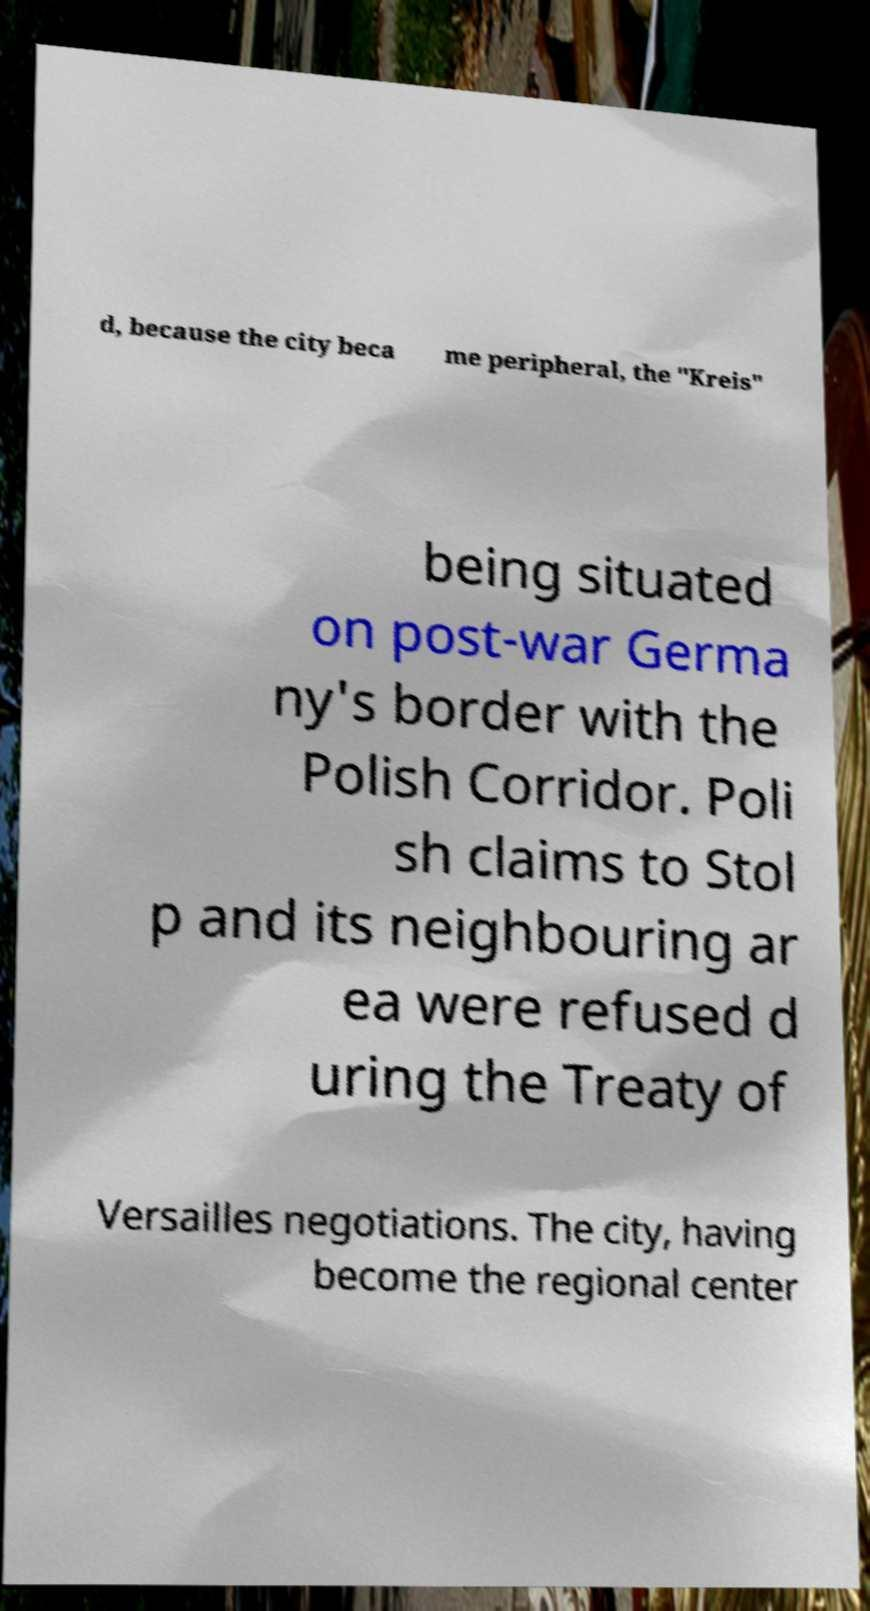There's text embedded in this image that I need extracted. Can you transcribe it verbatim? d, because the city beca me peripheral, the "Kreis" being situated on post-war Germa ny's border with the Polish Corridor. Poli sh claims to Stol p and its neighbouring ar ea were refused d uring the Treaty of Versailles negotiations. The city, having become the regional center 